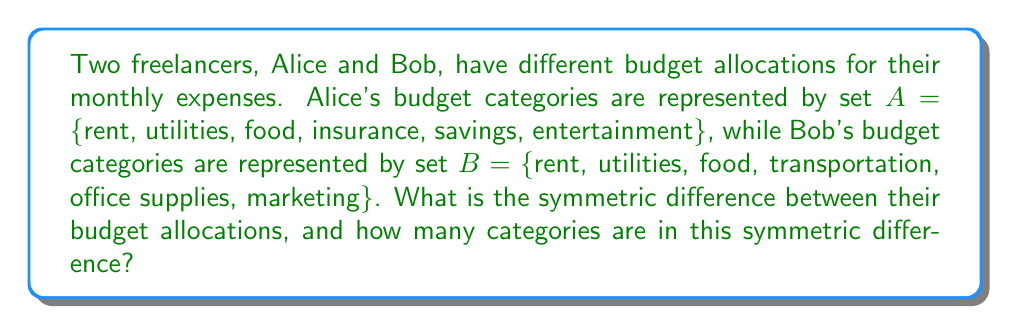Show me your answer to this math problem. To solve this problem, we need to understand the concept of symmetric difference in set theory and apply it to the given budget categories.

1. Symmetric Difference:
   The symmetric difference between two sets A and B, denoted as $A \triangle B$, is defined as the set of elements that are in either A or B, but not in both. It can be expressed as:

   $$A \triangle B = (A \setminus B) \cup (B \setminus A)$$

   where $\setminus$ represents set difference.

2. Identify unique elements in each set:
   A \ B = {insurance, savings, entertainment}
   B \ A = {transportation, office supplies, marketing}

3. Calculate the symmetric difference:
   $$A \triangle B = \{insurance, savings, entertainment, transportation, office supplies, marketing\}$$

4. Count the number of elements in the symmetric difference:
   The symmetric difference contains 6 elements.

This result shows the budget categories that are unique to each freelancer's allocation, which could be important for the financial advisor to discuss with them when developing a comprehensive budget strategy.
Answer: The symmetric difference is $A \triangle B = \{insurance, savings, entertainment, transportation, office supplies, marketing\}$, and it contains 6 categories. 